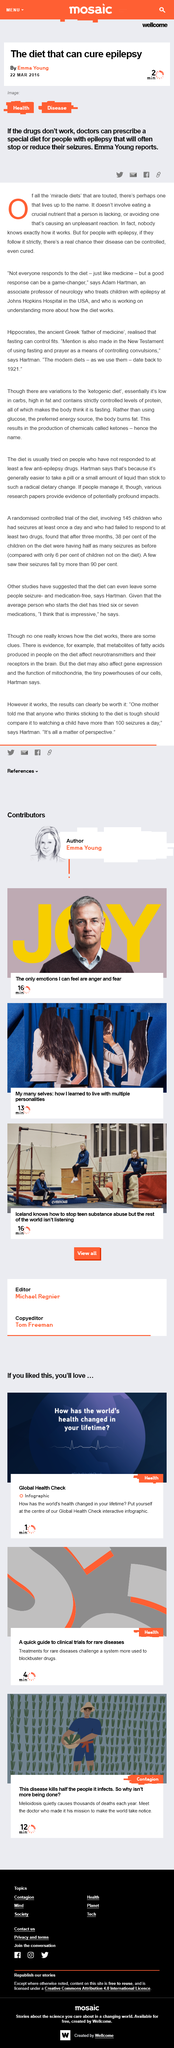Specify some key components in this picture. The estimated duration of the 'My many selves' article is 13 minutes. Dr. Adam Hartman teaches Neurology. If the drugs used to treat epilepsy are not effective, doctors can prescribe a special diet for patients as an alternative means of reducing or stopping seizures. By positioning oneself at the center of the Global Health Check interactive infographic, one can determine how the world's health has changed throughout their lifetime. Melioidosis is a disease that is known to cause high mortality rates, with studies indicating that up to half of the people who become infected with the bacteria may die as a result of the infection. 